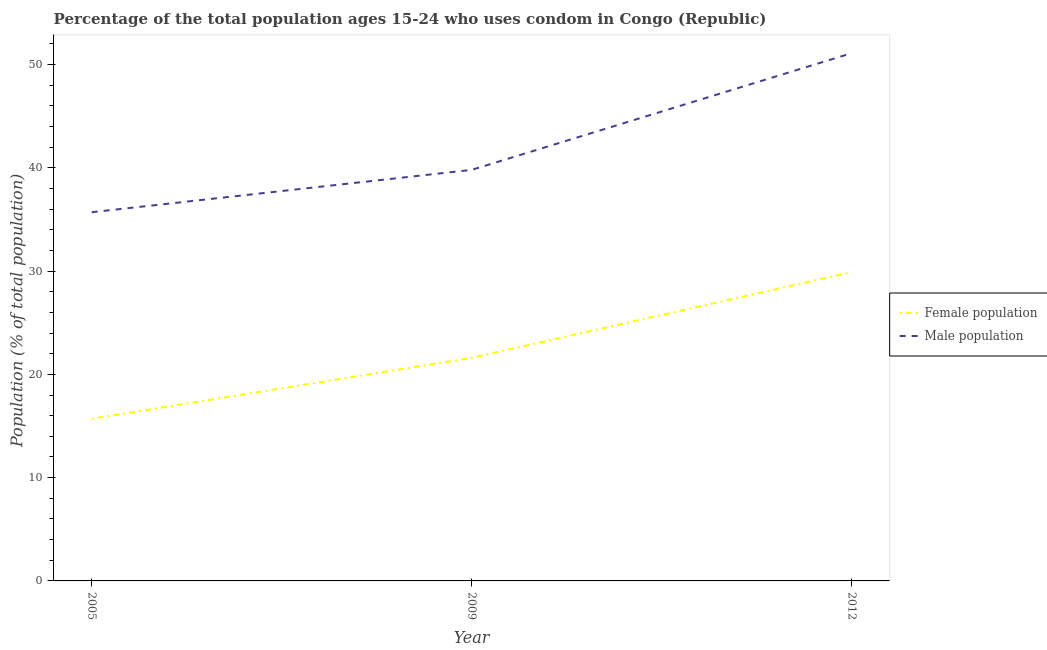Does the line corresponding to female population intersect with the line corresponding to male population?
Offer a very short reply. No. What is the female population in 2012?
Offer a very short reply. 29.9. Across all years, what is the maximum male population?
Provide a succinct answer. 51.1. Across all years, what is the minimum female population?
Offer a terse response. 15.7. In which year was the male population maximum?
Make the answer very short. 2012. In which year was the female population minimum?
Offer a terse response. 2005. What is the total female population in the graph?
Offer a very short reply. 67.2. What is the difference between the male population in 2005 and that in 2012?
Offer a terse response. -15.4. What is the difference between the male population in 2009 and the female population in 2012?
Give a very brief answer. 9.9. What is the average male population per year?
Make the answer very short. 42.2. In the year 2005, what is the difference between the female population and male population?
Offer a terse response. -20. In how many years, is the male population greater than 4 %?
Provide a short and direct response. 3. What is the ratio of the female population in 2005 to that in 2012?
Your answer should be very brief. 0.53. Is the female population in 2005 less than that in 2012?
Keep it short and to the point. Yes. What is the difference between the highest and the second highest female population?
Make the answer very short. 8.3. What is the difference between the highest and the lowest female population?
Offer a terse response. 14.2. In how many years, is the male population greater than the average male population taken over all years?
Give a very brief answer. 1. Does the female population monotonically increase over the years?
Your answer should be very brief. Yes. Is the female population strictly greater than the male population over the years?
Keep it short and to the point. No. Is the male population strictly less than the female population over the years?
Keep it short and to the point. No. How many lines are there?
Your answer should be very brief. 2. Are the values on the major ticks of Y-axis written in scientific E-notation?
Ensure brevity in your answer.  No. Does the graph contain any zero values?
Offer a very short reply. No. How many legend labels are there?
Your answer should be very brief. 2. How are the legend labels stacked?
Keep it short and to the point. Vertical. What is the title of the graph?
Give a very brief answer. Percentage of the total population ages 15-24 who uses condom in Congo (Republic). What is the label or title of the X-axis?
Offer a very short reply. Year. What is the label or title of the Y-axis?
Offer a terse response. Population (% of total population) . What is the Population (% of total population)  of Female population in 2005?
Offer a terse response. 15.7. What is the Population (% of total population)  in Male population in 2005?
Ensure brevity in your answer.  35.7. What is the Population (% of total population)  of Female population in 2009?
Your answer should be very brief. 21.6. What is the Population (% of total population)  of Male population in 2009?
Give a very brief answer. 39.8. What is the Population (% of total population)  of Female population in 2012?
Ensure brevity in your answer.  29.9. What is the Population (% of total population)  in Male population in 2012?
Your response must be concise. 51.1. Across all years, what is the maximum Population (% of total population)  in Female population?
Your answer should be very brief. 29.9. Across all years, what is the maximum Population (% of total population)  of Male population?
Your answer should be compact. 51.1. Across all years, what is the minimum Population (% of total population)  of Male population?
Offer a terse response. 35.7. What is the total Population (% of total population)  in Female population in the graph?
Your answer should be very brief. 67.2. What is the total Population (% of total population)  of Male population in the graph?
Ensure brevity in your answer.  126.6. What is the difference between the Population (% of total population)  of Female population in 2005 and that in 2009?
Provide a short and direct response. -5.9. What is the difference between the Population (% of total population)  in Female population in 2005 and that in 2012?
Provide a succinct answer. -14.2. What is the difference between the Population (% of total population)  of Male population in 2005 and that in 2012?
Ensure brevity in your answer.  -15.4. What is the difference between the Population (% of total population)  in Male population in 2009 and that in 2012?
Give a very brief answer. -11.3. What is the difference between the Population (% of total population)  of Female population in 2005 and the Population (% of total population)  of Male population in 2009?
Offer a very short reply. -24.1. What is the difference between the Population (% of total population)  in Female population in 2005 and the Population (% of total population)  in Male population in 2012?
Your response must be concise. -35.4. What is the difference between the Population (% of total population)  in Female population in 2009 and the Population (% of total population)  in Male population in 2012?
Provide a succinct answer. -29.5. What is the average Population (% of total population)  of Female population per year?
Offer a terse response. 22.4. What is the average Population (% of total population)  in Male population per year?
Keep it short and to the point. 42.2. In the year 2009, what is the difference between the Population (% of total population)  in Female population and Population (% of total population)  in Male population?
Keep it short and to the point. -18.2. In the year 2012, what is the difference between the Population (% of total population)  of Female population and Population (% of total population)  of Male population?
Your response must be concise. -21.2. What is the ratio of the Population (% of total population)  in Female population in 2005 to that in 2009?
Offer a terse response. 0.73. What is the ratio of the Population (% of total population)  in Male population in 2005 to that in 2009?
Keep it short and to the point. 0.9. What is the ratio of the Population (% of total population)  in Female population in 2005 to that in 2012?
Your answer should be compact. 0.53. What is the ratio of the Population (% of total population)  of Male population in 2005 to that in 2012?
Your answer should be very brief. 0.7. What is the ratio of the Population (% of total population)  in Female population in 2009 to that in 2012?
Ensure brevity in your answer.  0.72. What is the ratio of the Population (% of total population)  of Male population in 2009 to that in 2012?
Your answer should be compact. 0.78. What is the difference between the highest and the second highest Population (% of total population)  of Female population?
Provide a succinct answer. 8.3. What is the difference between the highest and the lowest Population (% of total population)  in Female population?
Your answer should be very brief. 14.2. What is the difference between the highest and the lowest Population (% of total population)  of Male population?
Give a very brief answer. 15.4. 